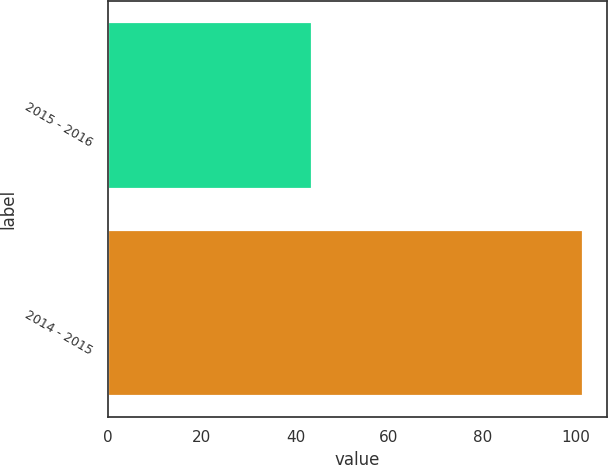Convert chart to OTSL. <chart><loc_0><loc_0><loc_500><loc_500><bar_chart><fcel>2015 - 2016<fcel>2014 - 2015<nl><fcel>43.6<fcel>101.5<nl></chart> 